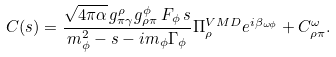<formula> <loc_0><loc_0><loc_500><loc_500>C ( s ) = \frac { \sqrt { 4 \pi \alpha } \, g ^ { \rho } _ { \pi \gamma } g ^ { \phi } _ { \rho \pi } \, F _ { \phi } \, s } { m _ { \phi } ^ { 2 } - s - i m _ { \phi } \Gamma _ { \phi } } \Pi _ { \rho } ^ { V M D } e ^ { i \beta _ { \omega \phi } } + C ^ { \omega } _ { \rho \pi } .</formula> 